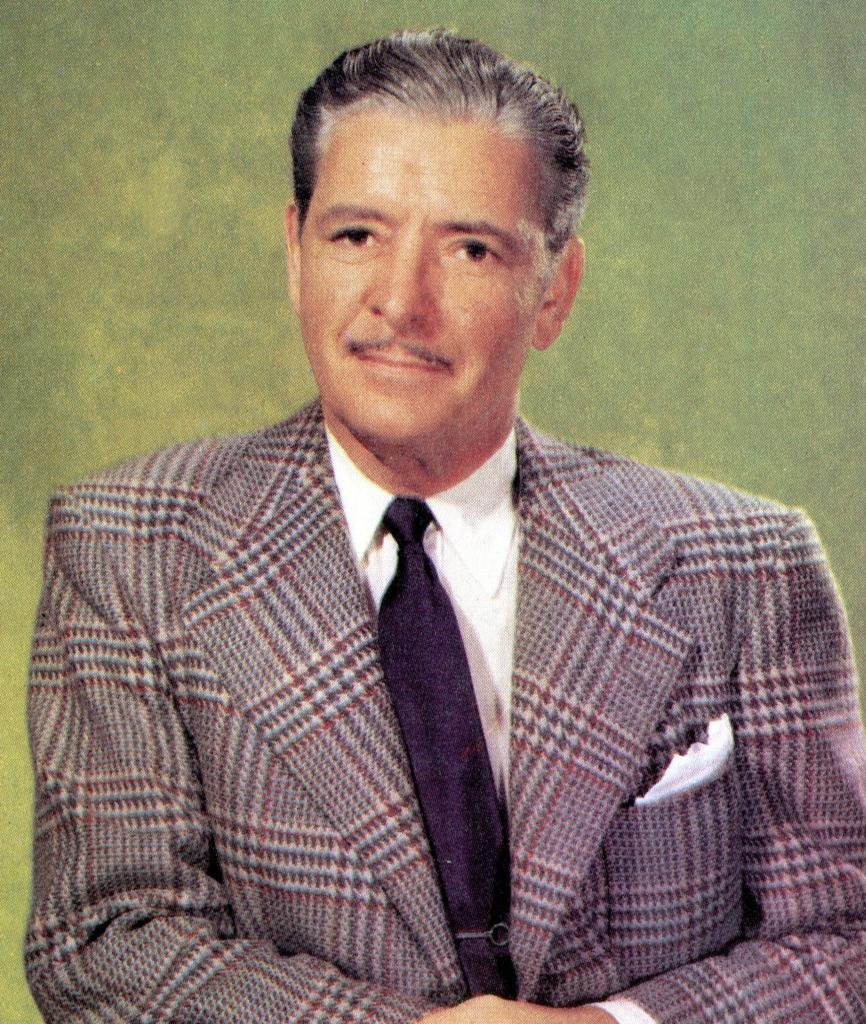What is the main subject in the image? There is a person in the image. What type of butter is being used by the person in the image? There is no butter present in the image; it only features a person. 